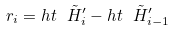Convert formula to latex. <formula><loc_0><loc_0><loc_500><loc_500>r _ { i } = h t \ \tilde { H } ^ { \prime } _ { i } - h t \ \tilde { H } ^ { \prime } _ { i - 1 }</formula> 